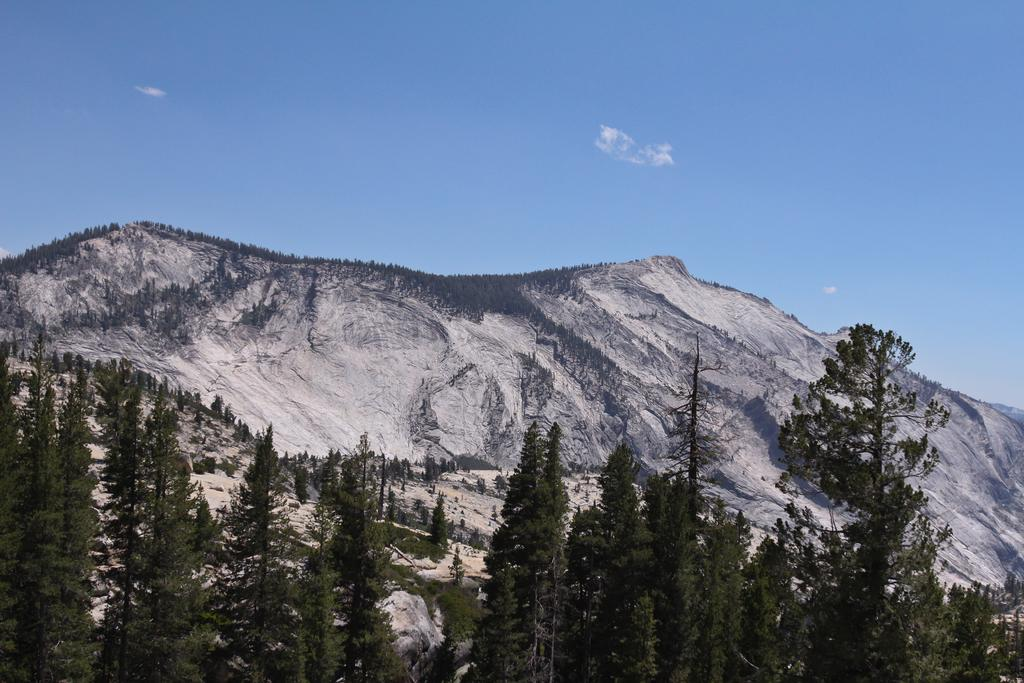What type of vegetation can be seen in the image? There are trees in the image. What type of geographical feature is present in the image? There are hills in the image. What is visible in the background of the image? The sky is visible in the background of the image. How many legs can be seen on the trees in the image? Trees do not have legs, so this question cannot be answered. 